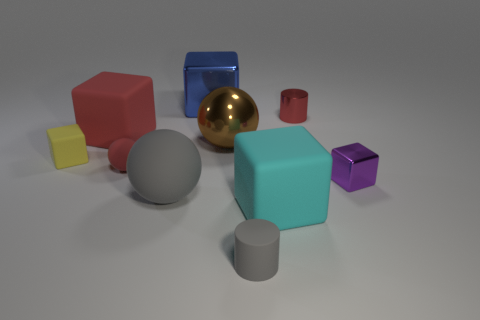Subtract all rubber spheres. How many spheres are left? 1 Subtract all cyan blocks. How many blocks are left? 4 Subtract all spheres. How many objects are left? 7 Subtract all brown rubber balls. Subtract all small red cylinders. How many objects are left? 9 Add 2 small red things. How many small red things are left? 4 Add 7 small gray rubber objects. How many small gray rubber objects exist? 8 Subtract 0 green cylinders. How many objects are left? 10 Subtract all brown cylinders. Subtract all brown spheres. How many cylinders are left? 2 